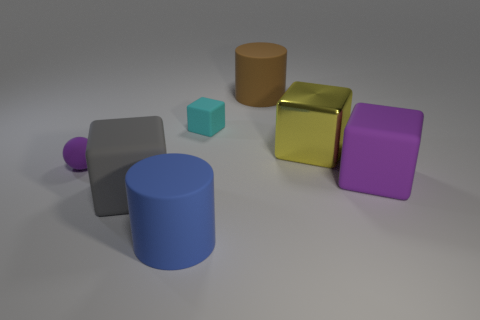Is there anything else that is the same material as the yellow thing?
Give a very brief answer. No. The large object that is the same color as the small rubber ball is what shape?
Provide a short and direct response. Cube. How many other objects are the same shape as the metallic object?
Your response must be concise. 3. Do the tiny sphere and the metal cube have the same color?
Offer a very short reply. No. There is a cube that is both to the left of the metal cube and on the right side of the big gray rubber cube; what material is it made of?
Make the answer very short. Rubber. What size is the gray matte object?
Make the answer very short. Large. What number of objects are in front of the big rubber cube that is right of the matte cylinder that is behind the large yellow thing?
Your answer should be compact. 2. The purple rubber thing to the right of the cylinder left of the small cyan rubber cube is what shape?
Make the answer very short. Cube. There is a purple thing that is the same shape as the gray rubber object; what size is it?
Offer a terse response. Large. Are there any other things that have the same size as the cyan rubber thing?
Offer a very short reply. Yes. 